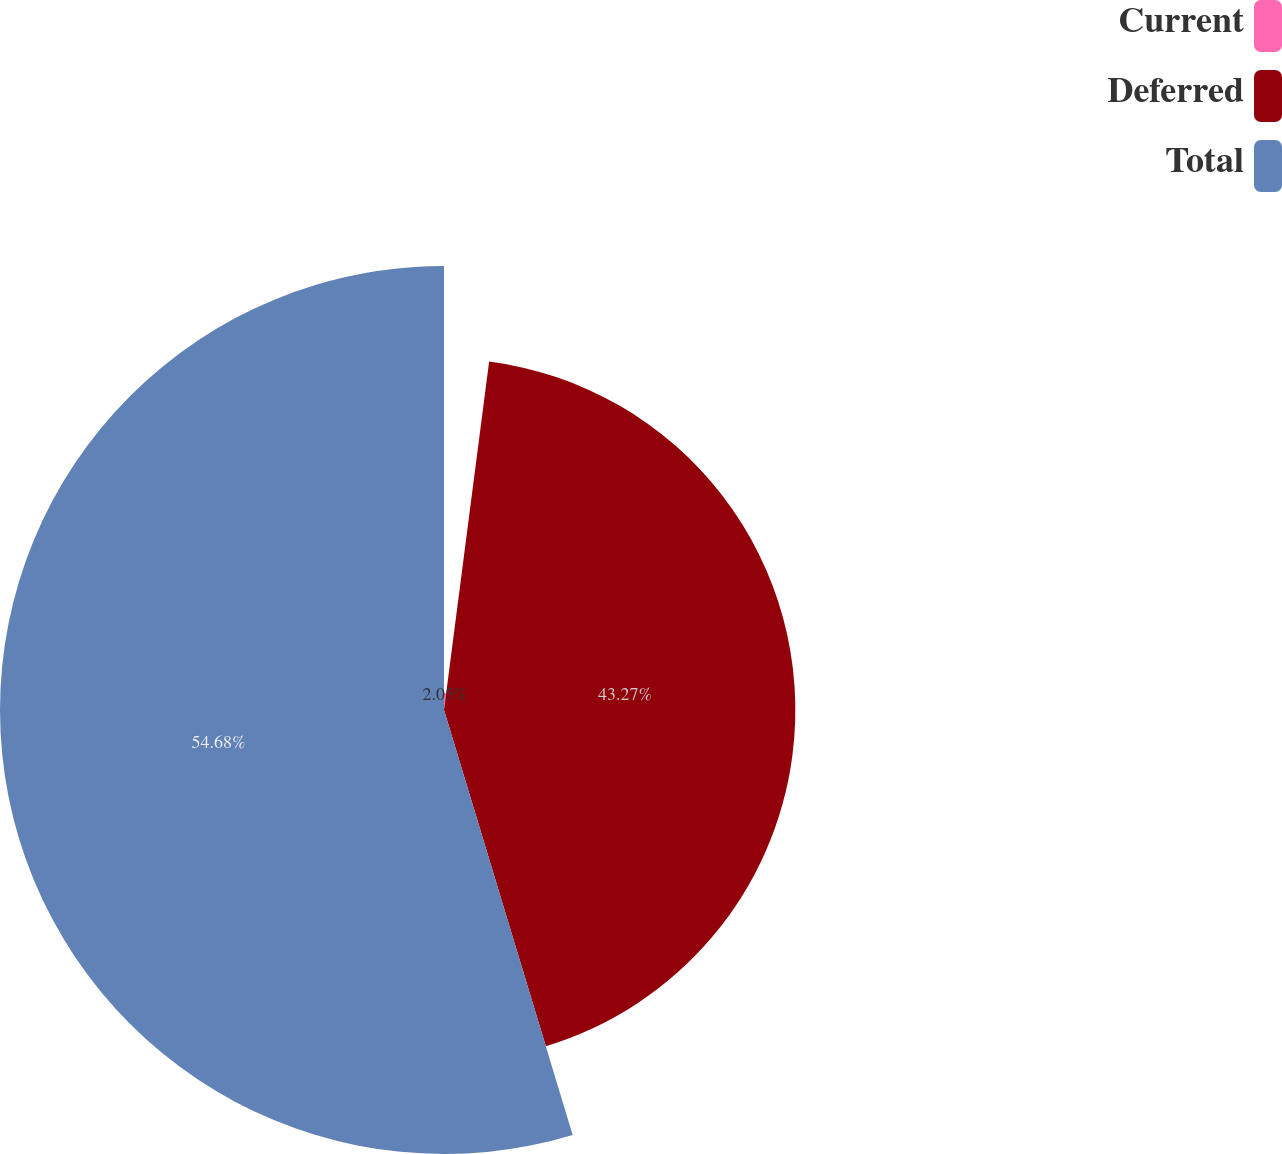Convert chart. <chart><loc_0><loc_0><loc_500><loc_500><pie_chart><fcel>Current<fcel>Deferred<fcel>Total<nl><fcel>2.05%<fcel>43.27%<fcel>54.68%<nl></chart> 